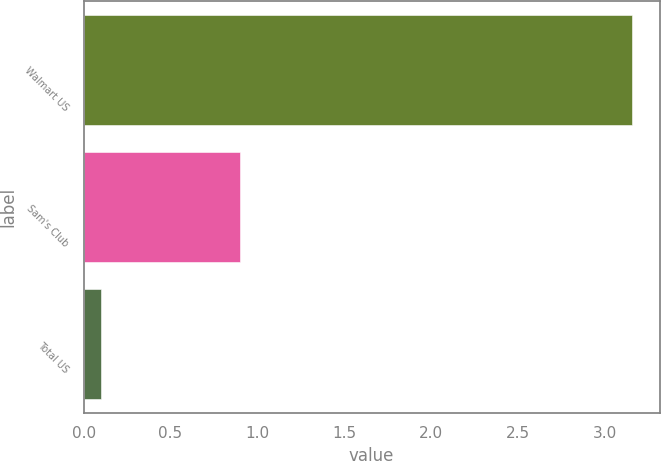Convert chart. <chart><loc_0><loc_0><loc_500><loc_500><bar_chart><fcel>Walmart US<fcel>Sam's Club<fcel>Total US<nl><fcel>3.16<fcel>0.9<fcel>0.1<nl></chart> 